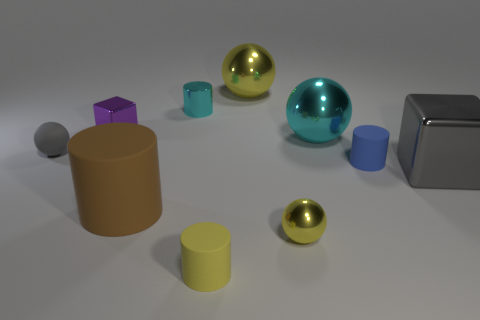There is a cylinder that is behind the small blue cylinder; does it have the same size as the gray thing that is right of the blue thing?
Offer a terse response. No. What is the material of the yellow sphere in front of the large metallic sphere that is to the right of the yellow object behind the cyan metallic sphere?
Keep it short and to the point. Metal. Does the gray sphere have the same size as the gray thing that is on the right side of the blue matte object?
Give a very brief answer. No. The small matte cylinder to the left of the small yellow metal sphere is what color?
Offer a terse response. Yellow. There is a yellow sphere that is behind the small metallic block; is there a metallic thing that is on the left side of it?
Ensure brevity in your answer.  Yes. What is the small cylinder that is in front of the large thing that is on the left side of the yellow cylinder made of?
Make the answer very short. Rubber. Is the purple metallic thing the same size as the metallic cylinder?
Your response must be concise. Yes. How big is the ball that is left of the tiny yellow shiny thing and to the right of the brown matte thing?
Keep it short and to the point. Large. The large brown object that is made of the same material as the small yellow cylinder is what shape?
Your answer should be very brief. Cylinder. Is the shape of the cyan object in front of the cyan metallic cylinder the same as the small shiny object that is to the right of the yellow matte object?
Your answer should be very brief. Yes. 